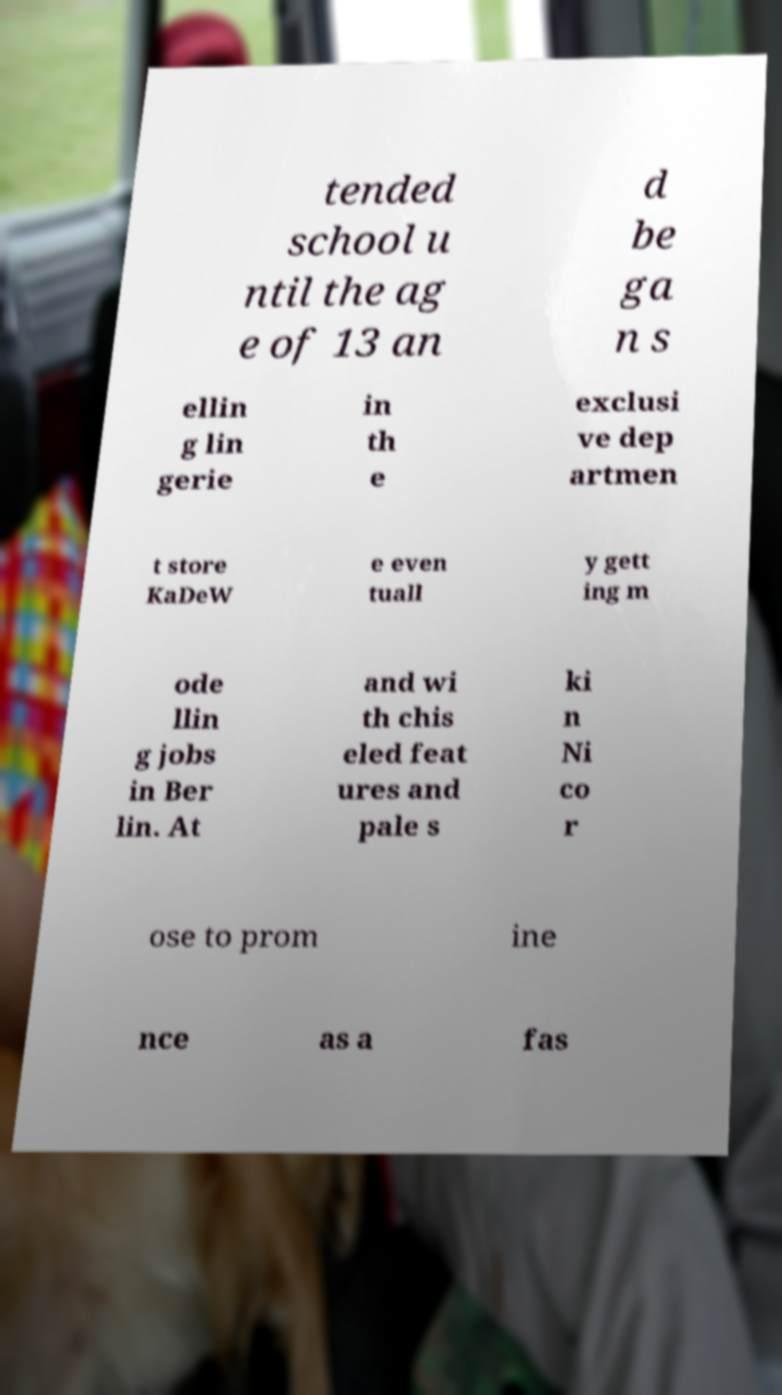What messages or text are displayed in this image? I need them in a readable, typed format. tended school u ntil the ag e of 13 an d be ga n s ellin g lin gerie in th e exclusi ve dep artmen t store KaDeW e even tuall y gett ing m ode llin g jobs in Ber lin. At and wi th chis eled feat ures and pale s ki n Ni co r ose to prom ine nce as a fas 